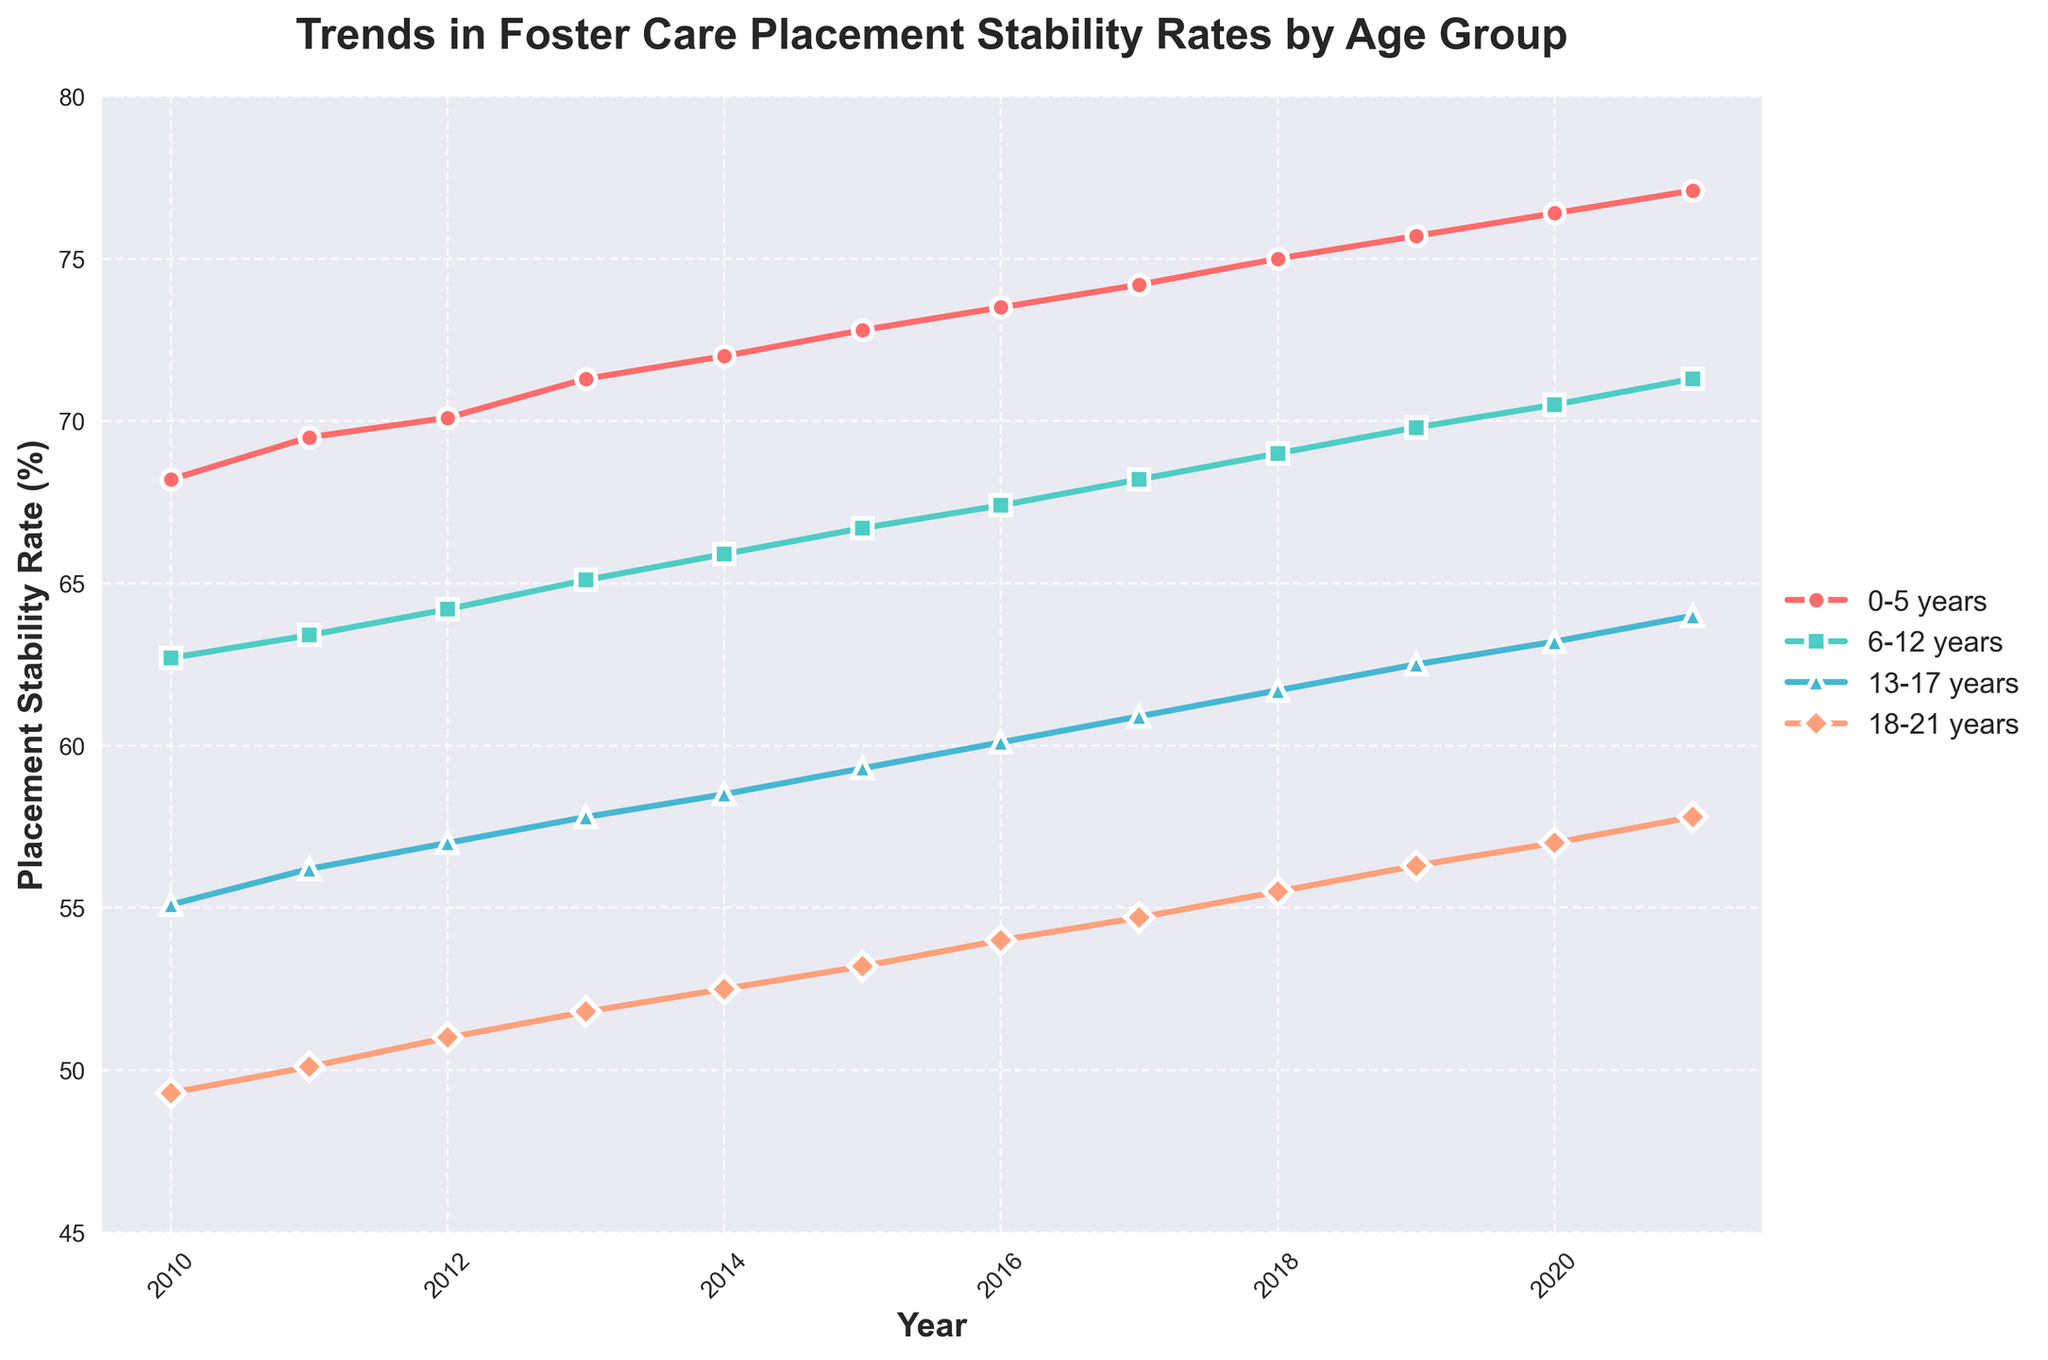What's the overall trend for placement stability rates in the 0-5 years age group from 2010 to 2021? The placement stability rates for the 0-5 years age group show a consistent upward trend from 68.2% in 2010 to 77.1% in 2021. This indicates an improved rate of placement stability over the years for this age group.
Answer: Upward trend Between which years do the 13-17 years age group see the largest increase in placement stability rates? To find the largest increase, compute the year-to-year differences. The differences are: 2010-2011: 56.2 - 55.1 = 1.1, 2011-2012: 57.0 - 56.2 = 0.8, 2012-2013: 57.8 - 57.0 = 0.8, 2013-2014: 58.5 - 57.8 = 0.7, 2014-2015: 59.3 - 58.5 = 0.8, 2015-2016: 60.1 - 59.3 = 0.8, 2016-2017: 60.9 - 60.1 = 0.8, 2017-2018: 61.7 - 60.9 = 0.8, 2018-2019: 62.5 - 61.7 = 0.8, 2019-2020: 63.2 - 62.5 = 0.7, 2020-2021: 64.0 - 63.2 = 0.8. The largest increase of 1.1 occurred between 2010 and 2011.
Answer: 2010-2011 Which age group consistently has the highest placement stability rate throughout the years shown? By observing the chart, the 0-5 years age group has the highest placement stability rate in each year from 2010 to 2021.
Answer: 0-5 years In 2015, what is the difference in placement stability rates between the 0-5 years and the 13-17 years age groups? In 2015, the placement stability rate for the 0-5 years age group is 72.8% and for the 13-17 years age group is 59.3%. The difference is 72.8 - 59.3 = 13.5%.
Answer: 13.5% Which age group shows the least variation in placement stability rates from 2010 to 2021? One way to find the least variation is to compute the range (maximum rate - minimum rate) for each age group: 0-5 years: 77.1 - 68.2 = 8.9, 6-12 years: 71.3 - 62.7 = 8.6, 13-17 years: 64.0 - 55.1 = 8.9, 18-21 years: 57.8 - 49.3 = 8.5. The age group 18-21 years has the least variation with a range of 8.5%.
Answer: 18-21 years How did the placement stability rate for the 18-21 years age group change from 2010 to 2021? The placement stability rate for the 18-21 years age group increased from 49.3% in 2010 to 57.8% in 2021. This is an upward trend indicating improvement over the 11-year period.
Answer: Increased What is the average placement stability rate for the 6-12 years age group over the entire period from 2010 to 2021? To find the average, sum all the rates for the 6-12 years age group and then divide by the total number of years. The sum is 62.7 + 63.4 + 64.2 + 65.1 + 65.9 + 66.7 + 67.4 + 68.2 + 69.0 + 69.8 + 70.5 + 71.3 = 804.2. Divide this by 12 to get the average: 804.2 / 12 = 67%.
Answer: 67% 